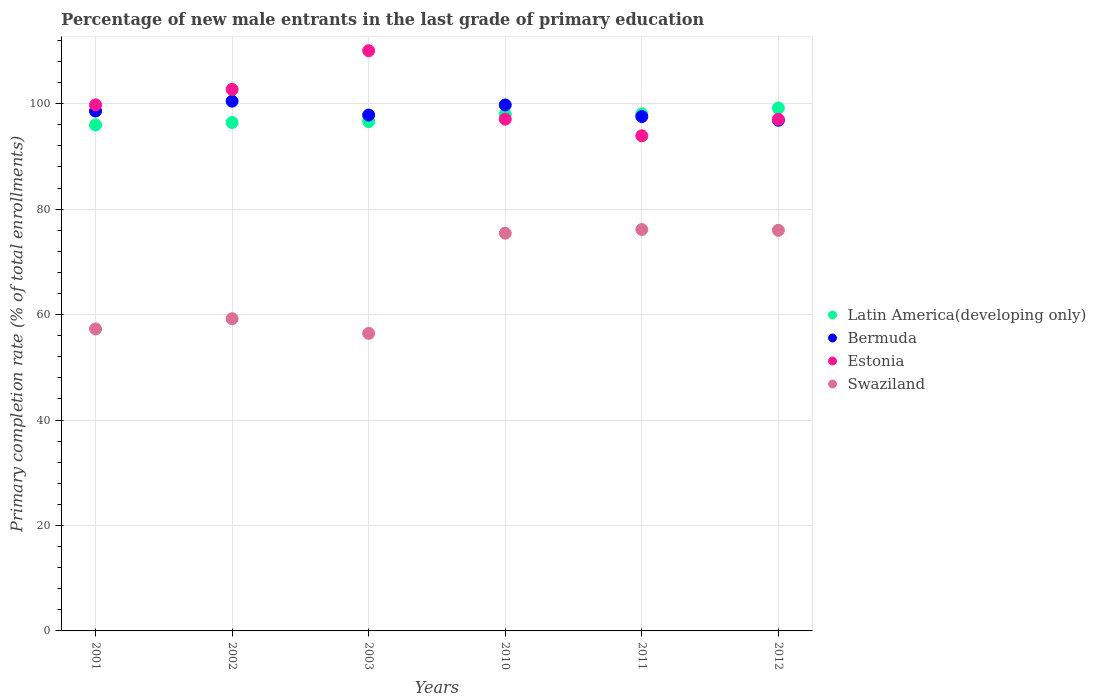Is the number of dotlines equal to the number of legend labels?
Your answer should be compact. Yes. What is the percentage of new male entrants in Latin America(developing only) in 2001?
Offer a very short reply. 95.97. Across all years, what is the maximum percentage of new male entrants in Latin America(developing only)?
Keep it short and to the point. 99.18. Across all years, what is the minimum percentage of new male entrants in Swaziland?
Your answer should be compact. 56.43. In which year was the percentage of new male entrants in Latin America(developing only) minimum?
Ensure brevity in your answer.  2001. What is the total percentage of new male entrants in Estonia in the graph?
Provide a short and direct response. 600.52. What is the difference between the percentage of new male entrants in Estonia in 2002 and that in 2003?
Ensure brevity in your answer.  -7.34. What is the difference between the percentage of new male entrants in Latin America(developing only) in 2003 and the percentage of new male entrants in Swaziland in 2001?
Offer a terse response. 39.34. What is the average percentage of new male entrants in Estonia per year?
Provide a succinct answer. 100.09. In the year 2012, what is the difference between the percentage of new male entrants in Bermuda and percentage of new male entrants in Latin America(developing only)?
Offer a terse response. -2.33. In how many years, is the percentage of new male entrants in Swaziland greater than 4 %?
Your answer should be compact. 6. What is the ratio of the percentage of new male entrants in Bermuda in 2010 to that in 2011?
Give a very brief answer. 1.02. What is the difference between the highest and the second highest percentage of new male entrants in Swaziland?
Offer a terse response. 0.14. What is the difference between the highest and the lowest percentage of new male entrants in Bermuda?
Your answer should be very brief. 3.62. In how many years, is the percentage of new male entrants in Latin America(developing only) greater than the average percentage of new male entrants in Latin America(developing only) taken over all years?
Your response must be concise. 3. Is the sum of the percentage of new male entrants in Bermuda in 2010 and 2012 greater than the maximum percentage of new male entrants in Estonia across all years?
Your answer should be very brief. Yes. Is it the case that in every year, the sum of the percentage of new male entrants in Swaziland and percentage of new male entrants in Latin America(developing only)  is greater than the sum of percentage of new male entrants in Bermuda and percentage of new male entrants in Estonia?
Give a very brief answer. No. Is the percentage of new male entrants in Latin America(developing only) strictly greater than the percentage of new male entrants in Swaziland over the years?
Make the answer very short. Yes. Is the percentage of new male entrants in Latin America(developing only) strictly less than the percentage of new male entrants in Swaziland over the years?
Offer a very short reply. No. How many dotlines are there?
Your response must be concise. 4. Are the values on the major ticks of Y-axis written in scientific E-notation?
Provide a succinct answer. No. Does the graph contain any zero values?
Provide a succinct answer. No. Does the graph contain grids?
Your answer should be very brief. Yes. Where does the legend appear in the graph?
Provide a short and direct response. Center right. What is the title of the graph?
Give a very brief answer. Percentage of new male entrants in the last grade of primary education. What is the label or title of the Y-axis?
Offer a very short reply. Primary completion rate (% of total enrollments). What is the Primary completion rate (% of total enrollments) in Latin America(developing only) in 2001?
Offer a terse response. 95.97. What is the Primary completion rate (% of total enrollments) of Bermuda in 2001?
Keep it short and to the point. 98.6. What is the Primary completion rate (% of total enrollments) of Estonia in 2001?
Make the answer very short. 99.77. What is the Primary completion rate (% of total enrollments) in Swaziland in 2001?
Give a very brief answer. 57.27. What is the Primary completion rate (% of total enrollments) in Latin America(developing only) in 2002?
Offer a terse response. 96.43. What is the Primary completion rate (% of total enrollments) of Bermuda in 2002?
Your answer should be very brief. 100.47. What is the Primary completion rate (% of total enrollments) in Estonia in 2002?
Your answer should be compact. 102.71. What is the Primary completion rate (% of total enrollments) in Swaziland in 2002?
Ensure brevity in your answer.  59.22. What is the Primary completion rate (% of total enrollments) in Latin America(developing only) in 2003?
Your response must be concise. 96.61. What is the Primary completion rate (% of total enrollments) in Bermuda in 2003?
Provide a succinct answer. 97.84. What is the Primary completion rate (% of total enrollments) in Estonia in 2003?
Your answer should be compact. 110.04. What is the Primary completion rate (% of total enrollments) of Swaziland in 2003?
Keep it short and to the point. 56.43. What is the Primary completion rate (% of total enrollments) in Latin America(developing only) in 2010?
Make the answer very short. 98.01. What is the Primary completion rate (% of total enrollments) in Bermuda in 2010?
Ensure brevity in your answer.  99.76. What is the Primary completion rate (% of total enrollments) in Estonia in 2010?
Offer a very short reply. 97.06. What is the Primary completion rate (% of total enrollments) of Swaziland in 2010?
Offer a very short reply. 75.43. What is the Primary completion rate (% of total enrollments) of Latin America(developing only) in 2011?
Provide a short and direct response. 98.06. What is the Primary completion rate (% of total enrollments) in Bermuda in 2011?
Offer a terse response. 97.56. What is the Primary completion rate (% of total enrollments) of Estonia in 2011?
Your response must be concise. 93.91. What is the Primary completion rate (% of total enrollments) of Swaziland in 2011?
Offer a very short reply. 76.13. What is the Primary completion rate (% of total enrollments) in Latin America(developing only) in 2012?
Provide a succinct answer. 99.18. What is the Primary completion rate (% of total enrollments) of Bermuda in 2012?
Offer a very short reply. 96.85. What is the Primary completion rate (% of total enrollments) in Estonia in 2012?
Provide a short and direct response. 97.03. What is the Primary completion rate (% of total enrollments) in Swaziland in 2012?
Make the answer very short. 75.98. Across all years, what is the maximum Primary completion rate (% of total enrollments) in Latin America(developing only)?
Your answer should be very brief. 99.18. Across all years, what is the maximum Primary completion rate (% of total enrollments) in Bermuda?
Ensure brevity in your answer.  100.47. Across all years, what is the maximum Primary completion rate (% of total enrollments) of Estonia?
Provide a succinct answer. 110.04. Across all years, what is the maximum Primary completion rate (% of total enrollments) of Swaziland?
Offer a terse response. 76.13. Across all years, what is the minimum Primary completion rate (% of total enrollments) in Latin America(developing only)?
Keep it short and to the point. 95.97. Across all years, what is the minimum Primary completion rate (% of total enrollments) in Bermuda?
Your answer should be very brief. 96.85. Across all years, what is the minimum Primary completion rate (% of total enrollments) of Estonia?
Offer a very short reply. 93.91. Across all years, what is the minimum Primary completion rate (% of total enrollments) of Swaziland?
Make the answer very short. 56.43. What is the total Primary completion rate (% of total enrollments) in Latin America(developing only) in the graph?
Offer a terse response. 584.25. What is the total Primary completion rate (% of total enrollments) in Bermuda in the graph?
Offer a very short reply. 591.08. What is the total Primary completion rate (% of total enrollments) in Estonia in the graph?
Provide a succinct answer. 600.52. What is the total Primary completion rate (% of total enrollments) of Swaziland in the graph?
Offer a terse response. 400.46. What is the difference between the Primary completion rate (% of total enrollments) in Latin America(developing only) in 2001 and that in 2002?
Provide a short and direct response. -0.46. What is the difference between the Primary completion rate (% of total enrollments) of Bermuda in 2001 and that in 2002?
Your response must be concise. -1.87. What is the difference between the Primary completion rate (% of total enrollments) in Estonia in 2001 and that in 2002?
Your response must be concise. -2.94. What is the difference between the Primary completion rate (% of total enrollments) in Swaziland in 2001 and that in 2002?
Give a very brief answer. -1.95. What is the difference between the Primary completion rate (% of total enrollments) in Latin America(developing only) in 2001 and that in 2003?
Keep it short and to the point. -0.64. What is the difference between the Primary completion rate (% of total enrollments) of Bermuda in 2001 and that in 2003?
Give a very brief answer. 0.76. What is the difference between the Primary completion rate (% of total enrollments) in Estonia in 2001 and that in 2003?
Keep it short and to the point. -10.27. What is the difference between the Primary completion rate (% of total enrollments) in Swaziland in 2001 and that in 2003?
Keep it short and to the point. 0.84. What is the difference between the Primary completion rate (% of total enrollments) in Latin America(developing only) in 2001 and that in 2010?
Your response must be concise. -2.04. What is the difference between the Primary completion rate (% of total enrollments) in Bermuda in 2001 and that in 2010?
Provide a succinct answer. -1.15. What is the difference between the Primary completion rate (% of total enrollments) of Estonia in 2001 and that in 2010?
Give a very brief answer. 2.71. What is the difference between the Primary completion rate (% of total enrollments) in Swaziland in 2001 and that in 2010?
Your answer should be compact. -18.16. What is the difference between the Primary completion rate (% of total enrollments) of Latin America(developing only) in 2001 and that in 2011?
Provide a short and direct response. -2.09. What is the difference between the Primary completion rate (% of total enrollments) of Bermuda in 2001 and that in 2011?
Your response must be concise. 1.04. What is the difference between the Primary completion rate (% of total enrollments) of Estonia in 2001 and that in 2011?
Provide a succinct answer. 5.86. What is the difference between the Primary completion rate (% of total enrollments) of Swaziland in 2001 and that in 2011?
Your answer should be compact. -18.86. What is the difference between the Primary completion rate (% of total enrollments) in Latin America(developing only) in 2001 and that in 2012?
Offer a very short reply. -3.21. What is the difference between the Primary completion rate (% of total enrollments) of Bermuda in 2001 and that in 2012?
Offer a very short reply. 1.75. What is the difference between the Primary completion rate (% of total enrollments) in Estonia in 2001 and that in 2012?
Provide a short and direct response. 2.74. What is the difference between the Primary completion rate (% of total enrollments) of Swaziland in 2001 and that in 2012?
Provide a succinct answer. -18.71. What is the difference between the Primary completion rate (% of total enrollments) of Latin America(developing only) in 2002 and that in 2003?
Provide a succinct answer. -0.18. What is the difference between the Primary completion rate (% of total enrollments) in Bermuda in 2002 and that in 2003?
Offer a very short reply. 2.64. What is the difference between the Primary completion rate (% of total enrollments) of Estonia in 2002 and that in 2003?
Provide a short and direct response. -7.34. What is the difference between the Primary completion rate (% of total enrollments) of Swaziland in 2002 and that in 2003?
Provide a succinct answer. 2.79. What is the difference between the Primary completion rate (% of total enrollments) of Latin America(developing only) in 2002 and that in 2010?
Make the answer very short. -1.58. What is the difference between the Primary completion rate (% of total enrollments) in Bermuda in 2002 and that in 2010?
Give a very brief answer. 0.72. What is the difference between the Primary completion rate (% of total enrollments) in Estonia in 2002 and that in 2010?
Your answer should be compact. 5.64. What is the difference between the Primary completion rate (% of total enrollments) of Swaziland in 2002 and that in 2010?
Your response must be concise. -16.21. What is the difference between the Primary completion rate (% of total enrollments) of Latin America(developing only) in 2002 and that in 2011?
Give a very brief answer. -1.63. What is the difference between the Primary completion rate (% of total enrollments) in Bermuda in 2002 and that in 2011?
Your answer should be compact. 2.91. What is the difference between the Primary completion rate (% of total enrollments) in Estonia in 2002 and that in 2011?
Ensure brevity in your answer.  8.8. What is the difference between the Primary completion rate (% of total enrollments) of Swaziland in 2002 and that in 2011?
Your response must be concise. -16.91. What is the difference between the Primary completion rate (% of total enrollments) of Latin America(developing only) in 2002 and that in 2012?
Ensure brevity in your answer.  -2.75. What is the difference between the Primary completion rate (% of total enrollments) in Bermuda in 2002 and that in 2012?
Make the answer very short. 3.62. What is the difference between the Primary completion rate (% of total enrollments) of Estonia in 2002 and that in 2012?
Give a very brief answer. 5.67. What is the difference between the Primary completion rate (% of total enrollments) in Swaziland in 2002 and that in 2012?
Your response must be concise. -16.77. What is the difference between the Primary completion rate (% of total enrollments) of Latin America(developing only) in 2003 and that in 2010?
Give a very brief answer. -1.4. What is the difference between the Primary completion rate (% of total enrollments) of Bermuda in 2003 and that in 2010?
Provide a succinct answer. -1.92. What is the difference between the Primary completion rate (% of total enrollments) in Estonia in 2003 and that in 2010?
Offer a terse response. 12.98. What is the difference between the Primary completion rate (% of total enrollments) of Swaziland in 2003 and that in 2010?
Offer a terse response. -19. What is the difference between the Primary completion rate (% of total enrollments) in Latin America(developing only) in 2003 and that in 2011?
Make the answer very short. -1.45. What is the difference between the Primary completion rate (% of total enrollments) of Bermuda in 2003 and that in 2011?
Provide a succinct answer. 0.28. What is the difference between the Primary completion rate (% of total enrollments) in Estonia in 2003 and that in 2011?
Give a very brief answer. 16.14. What is the difference between the Primary completion rate (% of total enrollments) of Swaziland in 2003 and that in 2011?
Make the answer very short. -19.7. What is the difference between the Primary completion rate (% of total enrollments) of Latin America(developing only) in 2003 and that in 2012?
Give a very brief answer. -2.57. What is the difference between the Primary completion rate (% of total enrollments) of Bermuda in 2003 and that in 2012?
Your answer should be compact. 0.98. What is the difference between the Primary completion rate (% of total enrollments) of Estonia in 2003 and that in 2012?
Your answer should be compact. 13.01. What is the difference between the Primary completion rate (% of total enrollments) of Swaziland in 2003 and that in 2012?
Ensure brevity in your answer.  -19.56. What is the difference between the Primary completion rate (% of total enrollments) of Latin America(developing only) in 2010 and that in 2011?
Offer a terse response. -0.05. What is the difference between the Primary completion rate (% of total enrollments) of Bermuda in 2010 and that in 2011?
Keep it short and to the point. 2.19. What is the difference between the Primary completion rate (% of total enrollments) of Estonia in 2010 and that in 2011?
Offer a very short reply. 3.15. What is the difference between the Primary completion rate (% of total enrollments) of Swaziland in 2010 and that in 2011?
Give a very brief answer. -0.7. What is the difference between the Primary completion rate (% of total enrollments) of Latin America(developing only) in 2010 and that in 2012?
Ensure brevity in your answer.  -1.17. What is the difference between the Primary completion rate (% of total enrollments) in Bermuda in 2010 and that in 2012?
Your answer should be very brief. 2.9. What is the difference between the Primary completion rate (% of total enrollments) of Estonia in 2010 and that in 2012?
Provide a short and direct response. 0.03. What is the difference between the Primary completion rate (% of total enrollments) of Swaziland in 2010 and that in 2012?
Give a very brief answer. -0.56. What is the difference between the Primary completion rate (% of total enrollments) of Latin America(developing only) in 2011 and that in 2012?
Your response must be concise. -1.12. What is the difference between the Primary completion rate (% of total enrollments) of Bermuda in 2011 and that in 2012?
Make the answer very short. 0.71. What is the difference between the Primary completion rate (% of total enrollments) in Estonia in 2011 and that in 2012?
Your answer should be compact. -3.12. What is the difference between the Primary completion rate (% of total enrollments) in Swaziland in 2011 and that in 2012?
Provide a short and direct response. 0.14. What is the difference between the Primary completion rate (% of total enrollments) in Latin America(developing only) in 2001 and the Primary completion rate (% of total enrollments) in Bermuda in 2002?
Offer a terse response. -4.51. What is the difference between the Primary completion rate (% of total enrollments) in Latin America(developing only) in 2001 and the Primary completion rate (% of total enrollments) in Estonia in 2002?
Your response must be concise. -6.74. What is the difference between the Primary completion rate (% of total enrollments) of Latin America(developing only) in 2001 and the Primary completion rate (% of total enrollments) of Swaziland in 2002?
Make the answer very short. 36.75. What is the difference between the Primary completion rate (% of total enrollments) of Bermuda in 2001 and the Primary completion rate (% of total enrollments) of Estonia in 2002?
Your answer should be compact. -4.1. What is the difference between the Primary completion rate (% of total enrollments) of Bermuda in 2001 and the Primary completion rate (% of total enrollments) of Swaziland in 2002?
Keep it short and to the point. 39.39. What is the difference between the Primary completion rate (% of total enrollments) in Estonia in 2001 and the Primary completion rate (% of total enrollments) in Swaziland in 2002?
Provide a short and direct response. 40.55. What is the difference between the Primary completion rate (% of total enrollments) of Latin America(developing only) in 2001 and the Primary completion rate (% of total enrollments) of Bermuda in 2003?
Provide a short and direct response. -1.87. What is the difference between the Primary completion rate (% of total enrollments) of Latin America(developing only) in 2001 and the Primary completion rate (% of total enrollments) of Estonia in 2003?
Provide a succinct answer. -14.08. What is the difference between the Primary completion rate (% of total enrollments) of Latin America(developing only) in 2001 and the Primary completion rate (% of total enrollments) of Swaziland in 2003?
Make the answer very short. 39.54. What is the difference between the Primary completion rate (% of total enrollments) in Bermuda in 2001 and the Primary completion rate (% of total enrollments) in Estonia in 2003?
Offer a terse response. -11.44. What is the difference between the Primary completion rate (% of total enrollments) in Bermuda in 2001 and the Primary completion rate (% of total enrollments) in Swaziland in 2003?
Offer a terse response. 42.17. What is the difference between the Primary completion rate (% of total enrollments) of Estonia in 2001 and the Primary completion rate (% of total enrollments) of Swaziland in 2003?
Your answer should be compact. 43.34. What is the difference between the Primary completion rate (% of total enrollments) of Latin America(developing only) in 2001 and the Primary completion rate (% of total enrollments) of Bermuda in 2010?
Make the answer very short. -3.79. What is the difference between the Primary completion rate (% of total enrollments) in Latin America(developing only) in 2001 and the Primary completion rate (% of total enrollments) in Estonia in 2010?
Your response must be concise. -1.1. What is the difference between the Primary completion rate (% of total enrollments) in Latin America(developing only) in 2001 and the Primary completion rate (% of total enrollments) in Swaziland in 2010?
Your response must be concise. 20.54. What is the difference between the Primary completion rate (% of total enrollments) of Bermuda in 2001 and the Primary completion rate (% of total enrollments) of Estonia in 2010?
Ensure brevity in your answer.  1.54. What is the difference between the Primary completion rate (% of total enrollments) of Bermuda in 2001 and the Primary completion rate (% of total enrollments) of Swaziland in 2010?
Provide a succinct answer. 23.17. What is the difference between the Primary completion rate (% of total enrollments) of Estonia in 2001 and the Primary completion rate (% of total enrollments) of Swaziland in 2010?
Your answer should be very brief. 24.34. What is the difference between the Primary completion rate (% of total enrollments) of Latin America(developing only) in 2001 and the Primary completion rate (% of total enrollments) of Bermuda in 2011?
Ensure brevity in your answer.  -1.59. What is the difference between the Primary completion rate (% of total enrollments) of Latin America(developing only) in 2001 and the Primary completion rate (% of total enrollments) of Estonia in 2011?
Make the answer very short. 2.06. What is the difference between the Primary completion rate (% of total enrollments) in Latin America(developing only) in 2001 and the Primary completion rate (% of total enrollments) in Swaziland in 2011?
Make the answer very short. 19.84. What is the difference between the Primary completion rate (% of total enrollments) of Bermuda in 2001 and the Primary completion rate (% of total enrollments) of Estonia in 2011?
Provide a succinct answer. 4.69. What is the difference between the Primary completion rate (% of total enrollments) in Bermuda in 2001 and the Primary completion rate (% of total enrollments) in Swaziland in 2011?
Offer a terse response. 22.47. What is the difference between the Primary completion rate (% of total enrollments) of Estonia in 2001 and the Primary completion rate (% of total enrollments) of Swaziland in 2011?
Offer a very short reply. 23.64. What is the difference between the Primary completion rate (% of total enrollments) of Latin America(developing only) in 2001 and the Primary completion rate (% of total enrollments) of Bermuda in 2012?
Make the answer very short. -0.89. What is the difference between the Primary completion rate (% of total enrollments) of Latin America(developing only) in 2001 and the Primary completion rate (% of total enrollments) of Estonia in 2012?
Provide a short and direct response. -1.06. What is the difference between the Primary completion rate (% of total enrollments) of Latin America(developing only) in 2001 and the Primary completion rate (% of total enrollments) of Swaziland in 2012?
Offer a terse response. 19.98. What is the difference between the Primary completion rate (% of total enrollments) in Bermuda in 2001 and the Primary completion rate (% of total enrollments) in Estonia in 2012?
Offer a very short reply. 1.57. What is the difference between the Primary completion rate (% of total enrollments) of Bermuda in 2001 and the Primary completion rate (% of total enrollments) of Swaziland in 2012?
Offer a terse response. 22.62. What is the difference between the Primary completion rate (% of total enrollments) in Estonia in 2001 and the Primary completion rate (% of total enrollments) in Swaziland in 2012?
Provide a short and direct response. 23.78. What is the difference between the Primary completion rate (% of total enrollments) in Latin America(developing only) in 2002 and the Primary completion rate (% of total enrollments) in Bermuda in 2003?
Give a very brief answer. -1.41. What is the difference between the Primary completion rate (% of total enrollments) of Latin America(developing only) in 2002 and the Primary completion rate (% of total enrollments) of Estonia in 2003?
Give a very brief answer. -13.61. What is the difference between the Primary completion rate (% of total enrollments) in Latin America(developing only) in 2002 and the Primary completion rate (% of total enrollments) in Swaziland in 2003?
Ensure brevity in your answer.  40. What is the difference between the Primary completion rate (% of total enrollments) in Bermuda in 2002 and the Primary completion rate (% of total enrollments) in Estonia in 2003?
Offer a terse response. -9.57. What is the difference between the Primary completion rate (% of total enrollments) in Bermuda in 2002 and the Primary completion rate (% of total enrollments) in Swaziland in 2003?
Ensure brevity in your answer.  44.05. What is the difference between the Primary completion rate (% of total enrollments) in Estonia in 2002 and the Primary completion rate (% of total enrollments) in Swaziland in 2003?
Keep it short and to the point. 46.28. What is the difference between the Primary completion rate (% of total enrollments) of Latin America(developing only) in 2002 and the Primary completion rate (% of total enrollments) of Bermuda in 2010?
Provide a short and direct response. -3.33. What is the difference between the Primary completion rate (% of total enrollments) in Latin America(developing only) in 2002 and the Primary completion rate (% of total enrollments) in Estonia in 2010?
Make the answer very short. -0.63. What is the difference between the Primary completion rate (% of total enrollments) of Latin America(developing only) in 2002 and the Primary completion rate (% of total enrollments) of Swaziland in 2010?
Offer a very short reply. 21. What is the difference between the Primary completion rate (% of total enrollments) of Bermuda in 2002 and the Primary completion rate (% of total enrollments) of Estonia in 2010?
Your answer should be very brief. 3.41. What is the difference between the Primary completion rate (% of total enrollments) of Bermuda in 2002 and the Primary completion rate (% of total enrollments) of Swaziland in 2010?
Your answer should be very brief. 25.04. What is the difference between the Primary completion rate (% of total enrollments) in Estonia in 2002 and the Primary completion rate (% of total enrollments) in Swaziland in 2010?
Offer a terse response. 27.28. What is the difference between the Primary completion rate (% of total enrollments) in Latin America(developing only) in 2002 and the Primary completion rate (% of total enrollments) in Bermuda in 2011?
Offer a terse response. -1.13. What is the difference between the Primary completion rate (% of total enrollments) in Latin America(developing only) in 2002 and the Primary completion rate (% of total enrollments) in Estonia in 2011?
Ensure brevity in your answer.  2.52. What is the difference between the Primary completion rate (% of total enrollments) in Latin America(developing only) in 2002 and the Primary completion rate (% of total enrollments) in Swaziland in 2011?
Your response must be concise. 20.3. What is the difference between the Primary completion rate (% of total enrollments) in Bermuda in 2002 and the Primary completion rate (% of total enrollments) in Estonia in 2011?
Your answer should be very brief. 6.57. What is the difference between the Primary completion rate (% of total enrollments) of Bermuda in 2002 and the Primary completion rate (% of total enrollments) of Swaziland in 2011?
Make the answer very short. 24.34. What is the difference between the Primary completion rate (% of total enrollments) of Estonia in 2002 and the Primary completion rate (% of total enrollments) of Swaziland in 2011?
Your response must be concise. 26.58. What is the difference between the Primary completion rate (% of total enrollments) in Latin America(developing only) in 2002 and the Primary completion rate (% of total enrollments) in Bermuda in 2012?
Your answer should be compact. -0.42. What is the difference between the Primary completion rate (% of total enrollments) in Latin America(developing only) in 2002 and the Primary completion rate (% of total enrollments) in Estonia in 2012?
Your answer should be very brief. -0.6. What is the difference between the Primary completion rate (% of total enrollments) of Latin America(developing only) in 2002 and the Primary completion rate (% of total enrollments) of Swaziland in 2012?
Ensure brevity in your answer.  20.44. What is the difference between the Primary completion rate (% of total enrollments) in Bermuda in 2002 and the Primary completion rate (% of total enrollments) in Estonia in 2012?
Your answer should be very brief. 3.44. What is the difference between the Primary completion rate (% of total enrollments) in Bermuda in 2002 and the Primary completion rate (% of total enrollments) in Swaziland in 2012?
Give a very brief answer. 24.49. What is the difference between the Primary completion rate (% of total enrollments) of Estonia in 2002 and the Primary completion rate (% of total enrollments) of Swaziland in 2012?
Make the answer very short. 26.72. What is the difference between the Primary completion rate (% of total enrollments) in Latin America(developing only) in 2003 and the Primary completion rate (% of total enrollments) in Bermuda in 2010?
Provide a succinct answer. -3.15. What is the difference between the Primary completion rate (% of total enrollments) in Latin America(developing only) in 2003 and the Primary completion rate (% of total enrollments) in Estonia in 2010?
Offer a very short reply. -0.46. What is the difference between the Primary completion rate (% of total enrollments) of Latin America(developing only) in 2003 and the Primary completion rate (% of total enrollments) of Swaziland in 2010?
Provide a short and direct response. 21.18. What is the difference between the Primary completion rate (% of total enrollments) in Bermuda in 2003 and the Primary completion rate (% of total enrollments) in Estonia in 2010?
Make the answer very short. 0.77. What is the difference between the Primary completion rate (% of total enrollments) in Bermuda in 2003 and the Primary completion rate (% of total enrollments) in Swaziland in 2010?
Keep it short and to the point. 22.41. What is the difference between the Primary completion rate (% of total enrollments) of Estonia in 2003 and the Primary completion rate (% of total enrollments) of Swaziland in 2010?
Ensure brevity in your answer.  34.61. What is the difference between the Primary completion rate (% of total enrollments) of Latin America(developing only) in 2003 and the Primary completion rate (% of total enrollments) of Bermuda in 2011?
Ensure brevity in your answer.  -0.95. What is the difference between the Primary completion rate (% of total enrollments) of Latin America(developing only) in 2003 and the Primary completion rate (% of total enrollments) of Estonia in 2011?
Your response must be concise. 2.7. What is the difference between the Primary completion rate (% of total enrollments) of Latin America(developing only) in 2003 and the Primary completion rate (% of total enrollments) of Swaziland in 2011?
Your answer should be very brief. 20.48. What is the difference between the Primary completion rate (% of total enrollments) of Bermuda in 2003 and the Primary completion rate (% of total enrollments) of Estonia in 2011?
Offer a very short reply. 3.93. What is the difference between the Primary completion rate (% of total enrollments) of Bermuda in 2003 and the Primary completion rate (% of total enrollments) of Swaziland in 2011?
Ensure brevity in your answer.  21.71. What is the difference between the Primary completion rate (% of total enrollments) in Estonia in 2003 and the Primary completion rate (% of total enrollments) in Swaziland in 2011?
Give a very brief answer. 33.91. What is the difference between the Primary completion rate (% of total enrollments) of Latin America(developing only) in 2003 and the Primary completion rate (% of total enrollments) of Bermuda in 2012?
Your response must be concise. -0.25. What is the difference between the Primary completion rate (% of total enrollments) of Latin America(developing only) in 2003 and the Primary completion rate (% of total enrollments) of Estonia in 2012?
Make the answer very short. -0.42. What is the difference between the Primary completion rate (% of total enrollments) in Latin America(developing only) in 2003 and the Primary completion rate (% of total enrollments) in Swaziland in 2012?
Your response must be concise. 20.62. What is the difference between the Primary completion rate (% of total enrollments) of Bermuda in 2003 and the Primary completion rate (% of total enrollments) of Estonia in 2012?
Make the answer very short. 0.81. What is the difference between the Primary completion rate (% of total enrollments) of Bermuda in 2003 and the Primary completion rate (% of total enrollments) of Swaziland in 2012?
Your answer should be very brief. 21.85. What is the difference between the Primary completion rate (% of total enrollments) of Estonia in 2003 and the Primary completion rate (% of total enrollments) of Swaziland in 2012?
Provide a short and direct response. 34.06. What is the difference between the Primary completion rate (% of total enrollments) in Latin America(developing only) in 2010 and the Primary completion rate (% of total enrollments) in Bermuda in 2011?
Your response must be concise. 0.45. What is the difference between the Primary completion rate (% of total enrollments) of Latin America(developing only) in 2010 and the Primary completion rate (% of total enrollments) of Estonia in 2011?
Your response must be concise. 4.1. What is the difference between the Primary completion rate (% of total enrollments) of Latin America(developing only) in 2010 and the Primary completion rate (% of total enrollments) of Swaziland in 2011?
Your answer should be compact. 21.88. What is the difference between the Primary completion rate (% of total enrollments) in Bermuda in 2010 and the Primary completion rate (% of total enrollments) in Estonia in 2011?
Provide a short and direct response. 5.85. What is the difference between the Primary completion rate (% of total enrollments) of Bermuda in 2010 and the Primary completion rate (% of total enrollments) of Swaziland in 2011?
Your answer should be very brief. 23.63. What is the difference between the Primary completion rate (% of total enrollments) of Estonia in 2010 and the Primary completion rate (% of total enrollments) of Swaziland in 2011?
Provide a succinct answer. 20.93. What is the difference between the Primary completion rate (% of total enrollments) in Latin America(developing only) in 2010 and the Primary completion rate (% of total enrollments) in Bermuda in 2012?
Give a very brief answer. 1.16. What is the difference between the Primary completion rate (% of total enrollments) in Latin America(developing only) in 2010 and the Primary completion rate (% of total enrollments) in Estonia in 2012?
Make the answer very short. 0.98. What is the difference between the Primary completion rate (% of total enrollments) in Latin America(developing only) in 2010 and the Primary completion rate (% of total enrollments) in Swaziland in 2012?
Make the answer very short. 22.02. What is the difference between the Primary completion rate (% of total enrollments) of Bermuda in 2010 and the Primary completion rate (% of total enrollments) of Estonia in 2012?
Ensure brevity in your answer.  2.72. What is the difference between the Primary completion rate (% of total enrollments) of Bermuda in 2010 and the Primary completion rate (% of total enrollments) of Swaziland in 2012?
Ensure brevity in your answer.  23.77. What is the difference between the Primary completion rate (% of total enrollments) in Estonia in 2010 and the Primary completion rate (% of total enrollments) in Swaziland in 2012?
Ensure brevity in your answer.  21.08. What is the difference between the Primary completion rate (% of total enrollments) in Latin America(developing only) in 2011 and the Primary completion rate (% of total enrollments) in Bermuda in 2012?
Provide a succinct answer. 1.21. What is the difference between the Primary completion rate (% of total enrollments) in Latin America(developing only) in 2011 and the Primary completion rate (% of total enrollments) in Estonia in 2012?
Provide a succinct answer. 1.03. What is the difference between the Primary completion rate (% of total enrollments) in Latin America(developing only) in 2011 and the Primary completion rate (% of total enrollments) in Swaziland in 2012?
Provide a succinct answer. 22.07. What is the difference between the Primary completion rate (% of total enrollments) in Bermuda in 2011 and the Primary completion rate (% of total enrollments) in Estonia in 2012?
Your answer should be very brief. 0.53. What is the difference between the Primary completion rate (% of total enrollments) of Bermuda in 2011 and the Primary completion rate (% of total enrollments) of Swaziland in 2012?
Keep it short and to the point. 21.58. What is the difference between the Primary completion rate (% of total enrollments) of Estonia in 2011 and the Primary completion rate (% of total enrollments) of Swaziland in 2012?
Ensure brevity in your answer.  17.92. What is the average Primary completion rate (% of total enrollments) of Latin America(developing only) per year?
Your response must be concise. 97.38. What is the average Primary completion rate (% of total enrollments) in Bermuda per year?
Your response must be concise. 98.51. What is the average Primary completion rate (% of total enrollments) in Estonia per year?
Offer a terse response. 100.09. What is the average Primary completion rate (% of total enrollments) in Swaziland per year?
Offer a very short reply. 66.74. In the year 2001, what is the difference between the Primary completion rate (% of total enrollments) of Latin America(developing only) and Primary completion rate (% of total enrollments) of Bermuda?
Keep it short and to the point. -2.63. In the year 2001, what is the difference between the Primary completion rate (% of total enrollments) of Latin America(developing only) and Primary completion rate (% of total enrollments) of Estonia?
Make the answer very short. -3.8. In the year 2001, what is the difference between the Primary completion rate (% of total enrollments) in Latin America(developing only) and Primary completion rate (% of total enrollments) in Swaziland?
Offer a terse response. 38.7. In the year 2001, what is the difference between the Primary completion rate (% of total enrollments) of Bermuda and Primary completion rate (% of total enrollments) of Estonia?
Offer a very short reply. -1.17. In the year 2001, what is the difference between the Primary completion rate (% of total enrollments) in Bermuda and Primary completion rate (% of total enrollments) in Swaziland?
Give a very brief answer. 41.33. In the year 2001, what is the difference between the Primary completion rate (% of total enrollments) of Estonia and Primary completion rate (% of total enrollments) of Swaziland?
Offer a very short reply. 42.5. In the year 2002, what is the difference between the Primary completion rate (% of total enrollments) in Latin America(developing only) and Primary completion rate (% of total enrollments) in Bermuda?
Make the answer very short. -4.04. In the year 2002, what is the difference between the Primary completion rate (% of total enrollments) in Latin America(developing only) and Primary completion rate (% of total enrollments) in Estonia?
Give a very brief answer. -6.28. In the year 2002, what is the difference between the Primary completion rate (% of total enrollments) of Latin America(developing only) and Primary completion rate (% of total enrollments) of Swaziland?
Offer a terse response. 37.21. In the year 2002, what is the difference between the Primary completion rate (% of total enrollments) in Bermuda and Primary completion rate (% of total enrollments) in Estonia?
Make the answer very short. -2.23. In the year 2002, what is the difference between the Primary completion rate (% of total enrollments) in Bermuda and Primary completion rate (% of total enrollments) in Swaziland?
Offer a very short reply. 41.26. In the year 2002, what is the difference between the Primary completion rate (% of total enrollments) in Estonia and Primary completion rate (% of total enrollments) in Swaziland?
Offer a very short reply. 43.49. In the year 2003, what is the difference between the Primary completion rate (% of total enrollments) of Latin America(developing only) and Primary completion rate (% of total enrollments) of Bermuda?
Your answer should be very brief. -1.23. In the year 2003, what is the difference between the Primary completion rate (% of total enrollments) of Latin America(developing only) and Primary completion rate (% of total enrollments) of Estonia?
Ensure brevity in your answer.  -13.44. In the year 2003, what is the difference between the Primary completion rate (% of total enrollments) of Latin America(developing only) and Primary completion rate (% of total enrollments) of Swaziland?
Make the answer very short. 40.18. In the year 2003, what is the difference between the Primary completion rate (% of total enrollments) of Bermuda and Primary completion rate (% of total enrollments) of Estonia?
Offer a very short reply. -12.21. In the year 2003, what is the difference between the Primary completion rate (% of total enrollments) in Bermuda and Primary completion rate (% of total enrollments) in Swaziland?
Make the answer very short. 41.41. In the year 2003, what is the difference between the Primary completion rate (% of total enrollments) in Estonia and Primary completion rate (% of total enrollments) in Swaziland?
Offer a very short reply. 53.62. In the year 2010, what is the difference between the Primary completion rate (% of total enrollments) in Latin America(developing only) and Primary completion rate (% of total enrollments) in Bermuda?
Offer a very short reply. -1.75. In the year 2010, what is the difference between the Primary completion rate (% of total enrollments) in Latin America(developing only) and Primary completion rate (% of total enrollments) in Estonia?
Give a very brief answer. 0.95. In the year 2010, what is the difference between the Primary completion rate (% of total enrollments) in Latin America(developing only) and Primary completion rate (% of total enrollments) in Swaziland?
Provide a succinct answer. 22.58. In the year 2010, what is the difference between the Primary completion rate (% of total enrollments) in Bermuda and Primary completion rate (% of total enrollments) in Estonia?
Provide a short and direct response. 2.69. In the year 2010, what is the difference between the Primary completion rate (% of total enrollments) in Bermuda and Primary completion rate (% of total enrollments) in Swaziland?
Your answer should be very brief. 24.33. In the year 2010, what is the difference between the Primary completion rate (% of total enrollments) in Estonia and Primary completion rate (% of total enrollments) in Swaziland?
Provide a short and direct response. 21.63. In the year 2011, what is the difference between the Primary completion rate (% of total enrollments) in Latin America(developing only) and Primary completion rate (% of total enrollments) in Bermuda?
Ensure brevity in your answer.  0.5. In the year 2011, what is the difference between the Primary completion rate (% of total enrollments) of Latin America(developing only) and Primary completion rate (% of total enrollments) of Estonia?
Give a very brief answer. 4.15. In the year 2011, what is the difference between the Primary completion rate (% of total enrollments) of Latin America(developing only) and Primary completion rate (% of total enrollments) of Swaziland?
Your answer should be very brief. 21.93. In the year 2011, what is the difference between the Primary completion rate (% of total enrollments) in Bermuda and Primary completion rate (% of total enrollments) in Estonia?
Give a very brief answer. 3.65. In the year 2011, what is the difference between the Primary completion rate (% of total enrollments) in Bermuda and Primary completion rate (% of total enrollments) in Swaziland?
Offer a very short reply. 21.43. In the year 2011, what is the difference between the Primary completion rate (% of total enrollments) in Estonia and Primary completion rate (% of total enrollments) in Swaziland?
Provide a succinct answer. 17.78. In the year 2012, what is the difference between the Primary completion rate (% of total enrollments) of Latin America(developing only) and Primary completion rate (% of total enrollments) of Bermuda?
Ensure brevity in your answer.  2.33. In the year 2012, what is the difference between the Primary completion rate (% of total enrollments) in Latin America(developing only) and Primary completion rate (% of total enrollments) in Estonia?
Your answer should be very brief. 2.15. In the year 2012, what is the difference between the Primary completion rate (% of total enrollments) of Latin America(developing only) and Primary completion rate (% of total enrollments) of Swaziland?
Offer a very short reply. 23.2. In the year 2012, what is the difference between the Primary completion rate (% of total enrollments) in Bermuda and Primary completion rate (% of total enrollments) in Estonia?
Ensure brevity in your answer.  -0.18. In the year 2012, what is the difference between the Primary completion rate (% of total enrollments) of Bermuda and Primary completion rate (% of total enrollments) of Swaziland?
Offer a terse response. 20.87. In the year 2012, what is the difference between the Primary completion rate (% of total enrollments) in Estonia and Primary completion rate (% of total enrollments) in Swaziland?
Offer a very short reply. 21.05. What is the ratio of the Primary completion rate (% of total enrollments) of Bermuda in 2001 to that in 2002?
Your answer should be compact. 0.98. What is the ratio of the Primary completion rate (% of total enrollments) in Estonia in 2001 to that in 2002?
Your answer should be very brief. 0.97. What is the ratio of the Primary completion rate (% of total enrollments) of Swaziland in 2001 to that in 2002?
Provide a succinct answer. 0.97. What is the ratio of the Primary completion rate (% of total enrollments) in Latin America(developing only) in 2001 to that in 2003?
Offer a terse response. 0.99. What is the ratio of the Primary completion rate (% of total enrollments) of Bermuda in 2001 to that in 2003?
Your answer should be very brief. 1.01. What is the ratio of the Primary completion rate (% of total enrollments) of Estonia in 2001 to that in 2003?
Your response must be concise. 0.91. What is the ratio of the Primary completion rate (% of total enrollments) in Swaziland in 2001 to that in 2003?
Provide a short and direct response. 1.01. What is the ratio of the Primary completion rate (% of total enrollments) in Latin America(developing only) in 2001 to that in 2010?
Keep it short and to the point. 0.98. What is the ratio of the Primary completion rate (% of total enrollments) in Bermuda in 2001 to that in 2010?
Your answer should be very brief. 0.99. What is the ratio of the Primary completion rate (% of total enrollments) in Estonia in 2001 to that in 2010?
Give a very brief answer. 1.03. What is the ratio of the Primary completion rate (% of total enrollments) of Swaziland in 2001 to that in 2010?
Give a very brief answer. 0.76. What is the ratio of the Primary completion rate (% of total enrollments) of Latin America(developing only) in 2001 to that in 2011?
Offer a terse response. 0.98. What is the ratio of the Primary completion rate (% of total enrollments) of Bermuda in 2001 to that in 2011?
Your response must be concise. 1.01. What is the ratio of the Primary completion rate (% of total enrollments) of Estonia in 2001 to that in 2011?
Your answer should be compact. 1.06. What is the ratio of the Primary completion rate (% of total enrollments) of Swaziland in 2001 to that in 2011?
Keep it short and to the point. 0.75. What is the ratio of the Primary completion rate (% of total enrollments) in Latin America(developing only) in 2001 to that in 2012?
Provide a succinct answer. 0.97. What is the ratio of the Primary completion rate (% of total enrollments) of Bermuda in 2001 to that in 2012?
Your response must be concise. 1.02. What is the ratio of the Primary completion rate (% of total enrollments) in Estonia in 2001 to that in 2012?
Make the answer very short. 1.03. What is the ratio of the Primary completion rate (% of total enrollments) of Swaziland in 2001 to that in 2012?
Keep it short and to the point. 0.75. What is the ratio of the Primary completion rate (% of total enrollments) in Estonia in 2002 to that in 2003?
Your answer should be very brief. 0.93. What is the ratio of the Primary completion rate (% of total enrollments) of Swaziland in 2002 to that in 2003?
Make the answer very short. 1.05. What is the ratio of the Primary completion rate (% of total enrollments) of Latin America(developing only) in 2002 to that in 2010?
Provide a short and direct response. 0.98. What is the ratio of the Primary completion rate (% of total enrollments) of Estonia in 2002 to that in 2010?
Provide a succinct answer. 1.06. What is the ratio of the Primary completion rate (% of total enrollments) of Swaziland in 2002 to that in 2010?
Provide a succinct answer. 0.79. What is the ratio of the Primary completion rate (% of total enrollments) in Latin America(developing only) in 2002 to that in 2011?
Offer a terse response. 0.98. What is the ratio of the Primary completion rate (% of total enrollments) in Bermuda in 2002 to that in 2011?
Your answer should be compact. 1.03. What is the ratio of the Primary completion rate (% of total enrollments) of Estonia in 2002 to that in 2011?
Offer a terse response. 1.09. What is the ratio of the Primary completion rate (% of total enrollments) of Latin America(developing only) in 2002 to that in 2012?
Provide a succinct answer. 0.97. What is the ratio of the Primary completion rate (% of total enrollments) in Bermuda in 2002 to that in 2012?
Your response must be concise. 1.04. What is the ratio of the Primary completion rate (% of total enrollments) in Estonia in 2002 to that in 2012?
Give a very brief answer. 1.06. What is the ratio of the Primary completion rate (% of total enrollments) in Swaziland in 2002 to that in 2012?
Provide a succinct answer. 0.78. What is the ratio of the Primary completion rate (% of total enrollments) in Latin America(developing only) in 2003 to that in 2010?
Your answer should be compact. 0.99. What is the ratio of the Primary completion rate (% of total enrollments) of Bermuda in 2003 to that in 2010?
Offer a very short reply. 0.98. What is the ratio of the Primary completion rate (% of total enrollments) of Estonia in 2003 to that in 2010?
Offer a very short reply. 1.13. What is the ratio of the Primary completion rate (% of total enrollments) of Swaziland in 2003 to that in 2010?
Keep it short and to the point. 0.75. What is the ratio of the Primary completion rate (% of total enrollments) in Latin America(developing only) in 2003 to that in 2011?
Offer a very short reply. 0.99. What is the ratio of the Primary completion rate (% of total enrollments) in Estonia in 2003 to that in 2011?
Provide a succinct answer. 1.17. What is the ratio of the Primary completion rate (% of total enrollments) of Swaziland in 2003 to that in 2011?
Keep it short and to the point. 0.74. What is the ratio of the Primary completion rate (% of total enrollments) of Bermuda in 2003 to that in 2012?
Your answer should be compact. 1.01. What is the ratio of the Primary completion rate (% of total enrollments) in Estonia in 2003 to that in 2012?
Provide a succinct answer. 1.13. What is the ratio of the Primary completion rate (% of total enrollments) of Swaziland in 2003 to that in 2012?
Make the answer very short. 0.74. What is the ratio of the Primary completion rate (% of total enrollments) of Bermuda in 2010 to that in 2011?
Provide a succinct answer. 1.02. What is the ratio of the Primary completion rate (% of total enrollments) in Estonia in 2010 to that in 2011?
Your answer should be compact. 1.03. What is the ratio of the Primary completion rate (% of total enrollments) of Latin America(developing only) in 2010 to that in 2012?
Your answer should be compact. 0.99. What is the ratio of the Primary completion rate (% of total enrollments) in Bermuda in 2010 to that in 2012?
Provide a succinct answer. 1.03. What is the ratio of the Primary completion rate (% of total enrollments) in Latin America(developing only) in 2011 to that in 2012?
Provide a succinct answer. 0.99. What is the ratio of the Primary completion rate (% of total enrollments) of Bermuda in 2011 to that in 2012?
Make the answer very short. 1.01. What is the ratio of the Primary completion rate (% of total enrollments) of Estonia in 2011 to that in 2012?
Offer a very short reply. 0.97. What is the difference between the highest and the second highest Primary completion rate (% of total enrollments) of Latin America(developing only)?
Provide a short and direct response. 1.12. What is the difference between the highest and the second highest Primary completion rate (% of total enrollments) of Bermuda?
Offer a terse response. 0.72. What is the difference between the highest and the second highest Primary completion rate (% of total enrollments) of Estonia?
Make the answer very short. 7.34. What is the difference between the highest and the second highest Primary completion rate (% of total enrollments) in Swaziland?
Ensure brevity in your answer.  0.14. What is the difference between the highest and the lowest Primary completion rate (% of total enrollments) in Latin America(developing only)?
Your answer should be very brief. 3.21. What is the difference between the highest and the lowest Primary completion rate (% of total enrollments) in Bermuda?
Your answer should be compact. 3.62. What is the difference between the highest and the lowest Primary completion rate (% of total enrollments) of Estonia?
Make the answer very short. 16.14. What is the difference between the highest and the lowest Primary completion rate (% of total enrollments) in Swaziland?
Make the answer very short. 19.7. 